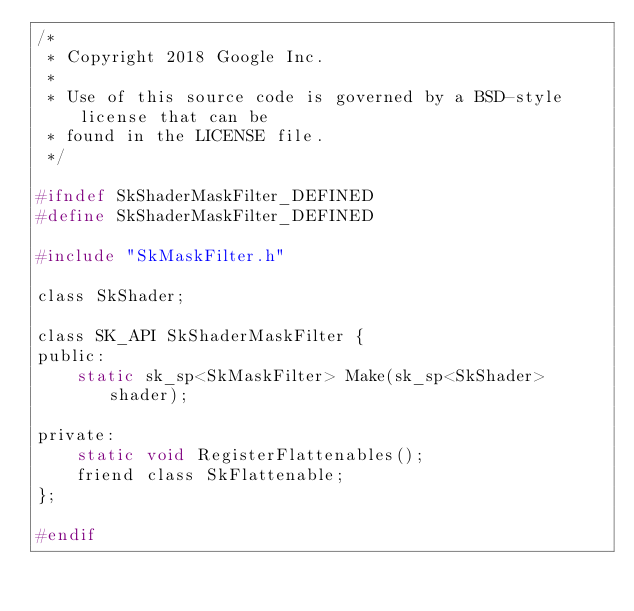Convert code to text. <code><loc_0><loc_0><loc_500><loc_500><_C_>/*
 * Copyright 2018 Google Inc.
 *
 * Use of this source code is governed by a BSD-style license that can be
 * found in the LICENSE file.
 */

#ifndef SkShaderMaskFilter_DEFINED
#define SkShaderMaskFilter_DEFINED

#include "SkMaskFilter.h"

class SkShader;

class SK_API SkShaderMaskFilter {
public:
    static sk_sp<SkMaskFilter> Make(sk_sp<SkShader> shader);

private:
    static void RegisterFlattenables();
    friend class SkFlattenable;
};

#endif
</code> 